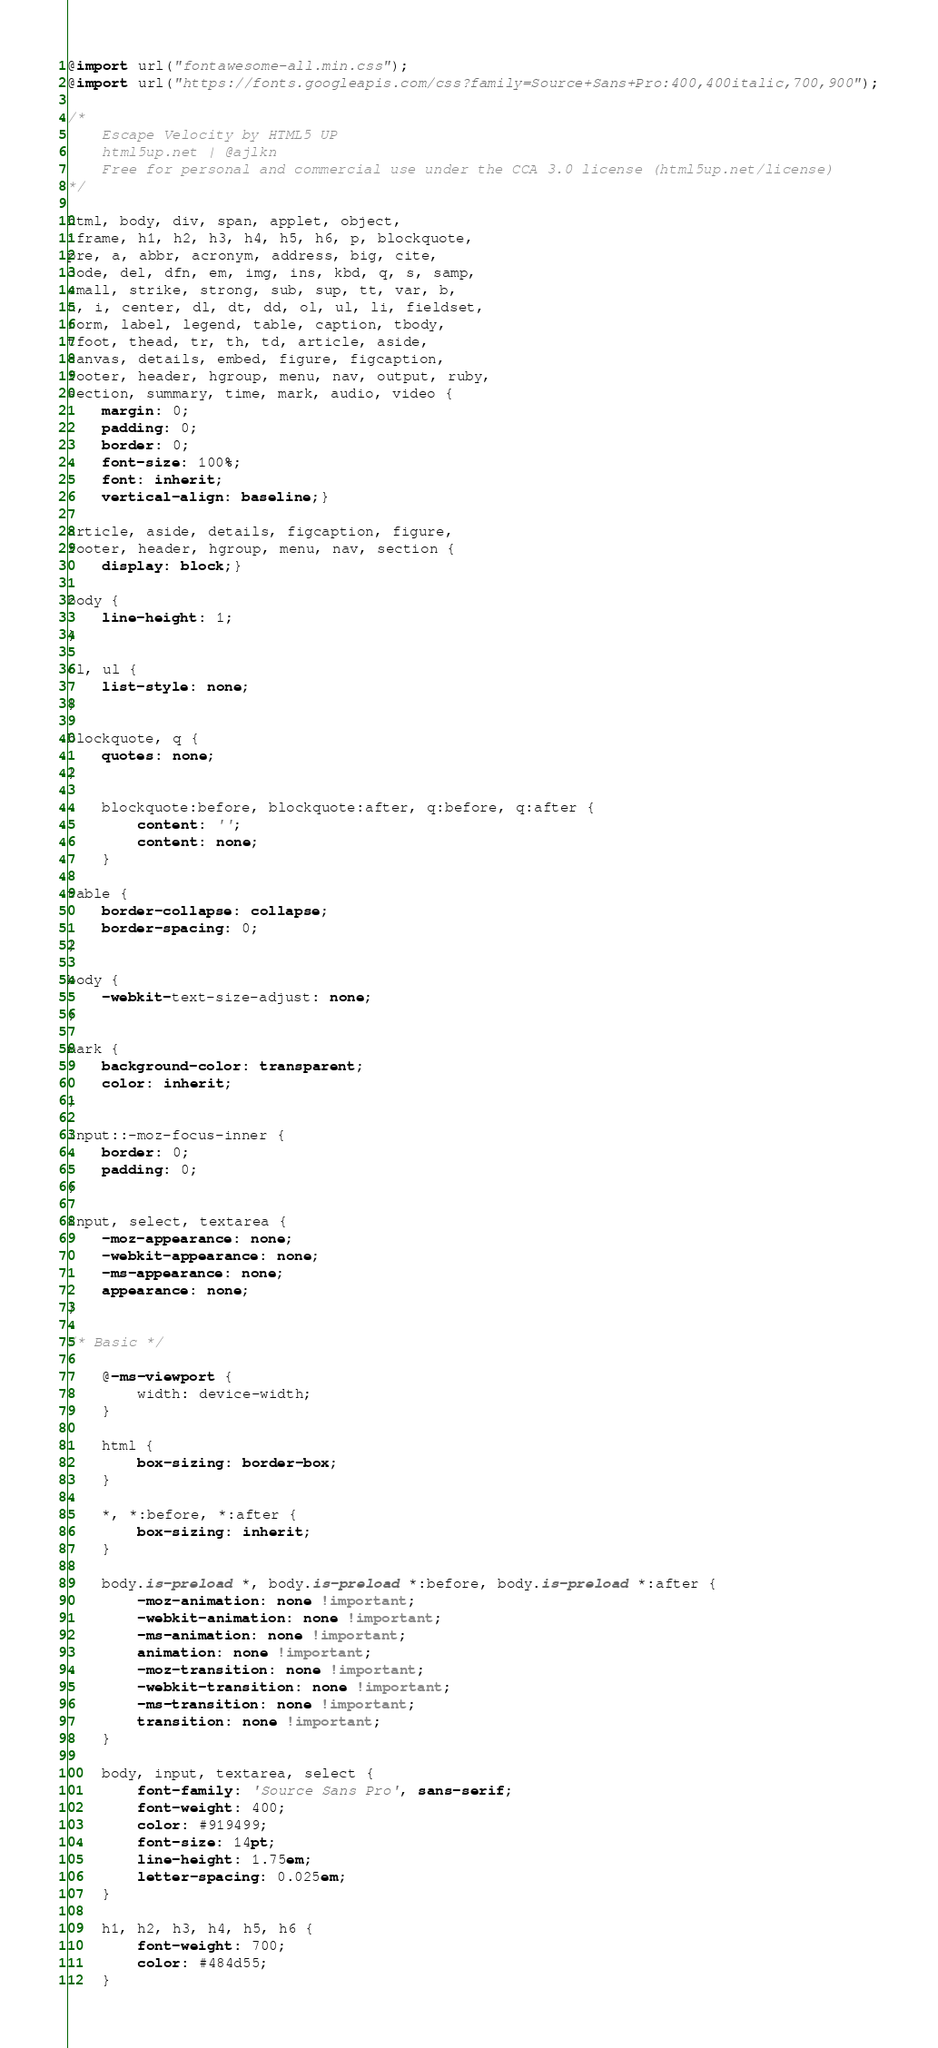<code> <loc_0><loc_0><loc_500><loc_500><_CSS_>@import url("fontawesome-all.min.css");
@import url("https://fonts.googleapis.com/css?family=Source+Sans+Pro:400,400italic,700,900");

/*
	Escape Velocity by HTML5 UP
	html5up.net | @ajlkn
	Free for personal and commercial use under the CCA 3.0 license (html5up.net/license)
*/

html, body, div, span, applet, object,
iframe, h1, h2, h3, h4, h5, h6, p, blockquote,
pre, a, abbr, acronym, address, big, cite,
code, del, dfn, em, img, ins, kbd, q, s, samp,
small, strike, strong, sub, sup, tt, var, b,
u, i, center, dl, dt, dd, ol, ul, li, fieldset,
form, label, legend, table, caption, tbody,
tfoot, thead, tr, th, td, article, aside,
canvas, details, embed, figure, figcaption,
footer, header, hgroup, menu, nav, output, ruby,
section, summary, time, mark, audio, video {
	margin: 0;
	padding: 0;
	border: 0;
	font-size: 100%;
	font: inherit;
	vertical-align: baseline;}

article, aside, details, figcaption, figure,
footer, header, hgroup, menu, nav, section {
	display: block;}

body {
	line-height: 1;
}

ol, ul {
	list-style: none;
}

blockquote, q {
	quotes: none;
}

	blockquote:before, blockquote:after, q:before, q:after {
		content: '';
		content: none;
	}

table {
	border-collapse: collapse;
	border-spacing: 0;
}

body {
	-webkit-text-size-adjust: none;
}

mark {
	background-color: transparent;
	color: inherit;
}

input::-moz-focus-inner {
	border: 0;
	padding: 0;
}

input, select, textarea {
	-moz-appearance: none;
	-webkit-appearance: none;
	-ms-appearance: none;
	appearance: none;
}

/* Basic */

	@-ms-viewport {
		width: device-width;
	}

	html {
		box-sizing: border-box;
	}

	*, *:before, *:after {
		box-sizing: inherit;
	}

	body.is-preload *, body.is-preload *:before, body.is-preload *:after {
		-moz-animation: none !important;
		-webkit-animation: none !important;
		-ms-animation: none !important;
		animation: none !important;
		-moz-transition: none !important;
		-webkit-transition: none !important;
		-ms-transition: none !important;
		transition: none !important;
	}

	body, input, textarea, select {
		font-family: 'Source Sans Pro', sans-serif;
		font-weight: 400;
		color: #919499;
		font-size: 14pt;
		line-height: 1.75em;
		letter-spacing: 0.025em;
	}

	h1, h2, h3, h4, h5, h6 {
		font-weight: 700;
		color: #484d55;
	}
</code> 